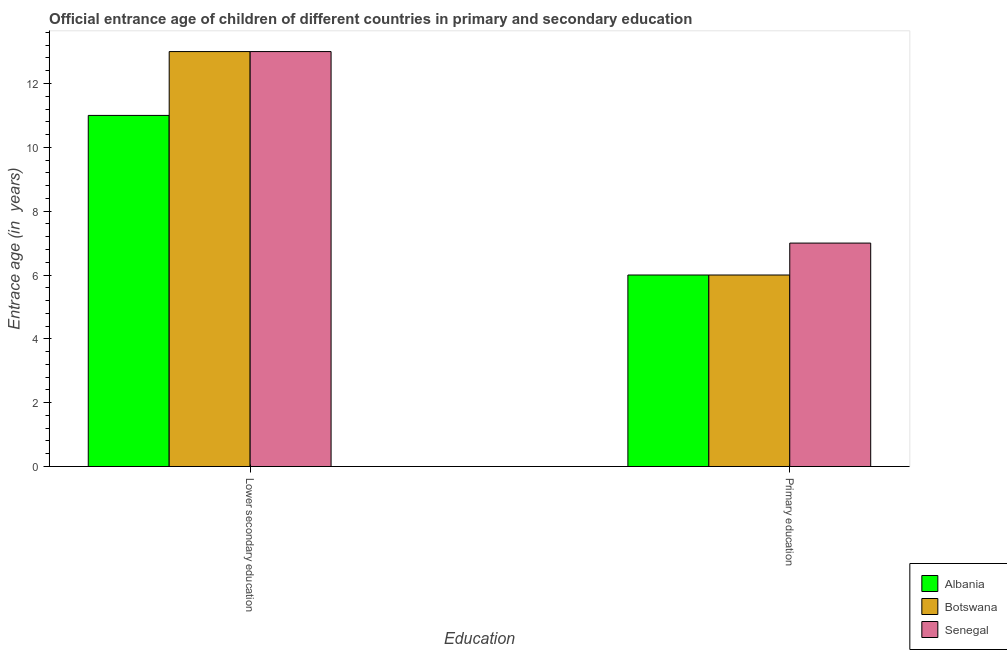Are the number of bars per tick equal to the number of legend labels?
Your response must be concise. Yes. What is the label of the 1st group of bars from the left?
Ensure brevity in your answer.  Lower secondary education. What is the entrance age of chiildren in primary education in Albania?
Ensure brevity in your answer.  6. Across all countries, what is the maximum entrance age of chiildren in primary education?
Make the answer very short. 7. Across all countries, what is the minimum entrance age of children in lower secondary education?
Your answer should be very brief. 11. In which country was the entrance age of chiildren in primary education maximum?
Offer a terse response. Senegal. In which country was the entrance age of chiildren in primary education minimum?
Your answer should be very brief. Albania. What is the total entrance age of children in lower secondary education in the graph?
Provide a succinct answer. 37. What is the difference between the entrance age of chiildren in primary education in Senegal and that in Albania?
Provide a short and direct response. 1. What is the difference between the entrance age of chiildren in primary education in Albania and the entrance age of children in lower secondary education in Senegal?
Ensure brevity in your answer.  -7. What is the average entrance age of children in lower secondary education per country?
Give a very brief answer. 12.33. What is the difference between the entrance age of children in lower secondary education and entrance age of chiildren in primary education in Albania?
Offer a very short reply. 5. In how many countries, is the entrance age of children in lower secondary education greater than 3.6 years?
Offer a terse response. 3. What is the ratio of the entrance age of children in lower secondary education in Senegal to that in Albania?
Give a very brief answer. 1.18. What does the 2nd bar from the left in Primary education represents?
Your response must be concise. Botswana. What does the 3rd bar from the right in Lower secondary education represents?
Your answer should be compact. Albania. How many bars are there?
Provide a short and direct response. 6. How many countries are there in the graph?
Provide a succinct answer. 3. What is the difference between two consecutive major ticks on the Y-axis?
Your response must be concise. 2. Does the graph contain grids?
Keep it short and to the point. No. How many legend labels are there?
Offer a terse response. 3. What is the title of the graph?
Keep it short and to the point. Official entrance age of children of different countries in primary and secondary education. Does "Equatorial Guinea" appear as one of the legend labels in the graph?
Ensure brevity in your answer.  No. What is the label or title of the X-axis?
Give a very brief answer. Education. What is the label or title of the Y-axis?
Provide a short and direct response. Entrace age (in  years). What is the Entrace age (in  years) of Albania in Lower secondary education?
Ensure brevity in your answer.  11. What is the Entrace age (in  years) of Senegal in Lower secondary education?
Ensure brevity in your answer.  13. What is the Entrace age (in  years) in Albania in Primary education?
Offer a very short reply. 6. Across all Education, what is the maximum Entrace age (in  years) in Botswana?
Ensure brevity in your answer.  13. Across all Education, what is the minimum Entrace age (in  years) of Albania?
Provide a succinct answer. 6. Across all Education, what is the minimum Entrace age (in  years) of Botswana?
Make the answer very short. 6. What is the total Entrace age (in  years) in Albania in the graph?
Keep it short and to the point. 17. What is the total Entrace age (in  years) in Botswana in the graph?
Your answer should be compact. 19. What is the difference between the Entrace age (in  years) of Albania in Lower secondary education and that in Primary education?
Your response must be concise. 5. What is the average Entrace age (in  years) of Albania per Education?
Make the answer very short. 8.5. What is the average Entrace age (in  years) in Botswana per Education?
Offer a very short reply. 9.5. What is the average Entrace age (in  years) in Senegal per Education?
Offer a terse response. 10. What is the difference between the Entrace age (in  years) in Albania and Entrace age (in  years) in Botswana in Lower secondary education?
Provide a short and direct response. -2. What is the difference between the Entrace age (in  years) in Albania and Entrace age (in  years) in Senegal in Lower secondary education?
Your answer should be compact. -2. What is the ratio of the Entrace age (in  years) of Albania in Lower secondary education to that in Primary education?
Ensure brevity in your answer.  1.83. What is the ratio of the Entrace age (in  years) of Botswana in Lower secondary education to that in Primary education?
Your answer should be compact. 2.17. What is the ratio of the Entrace age (in  years) of Senegal in Lower secondary education to that in Primary education?
Provide a short and direct response. 1.86. What is the difference between the highest and the lowest Entrace age (in  years) in Albania?
Your answer should be compact. 5. 